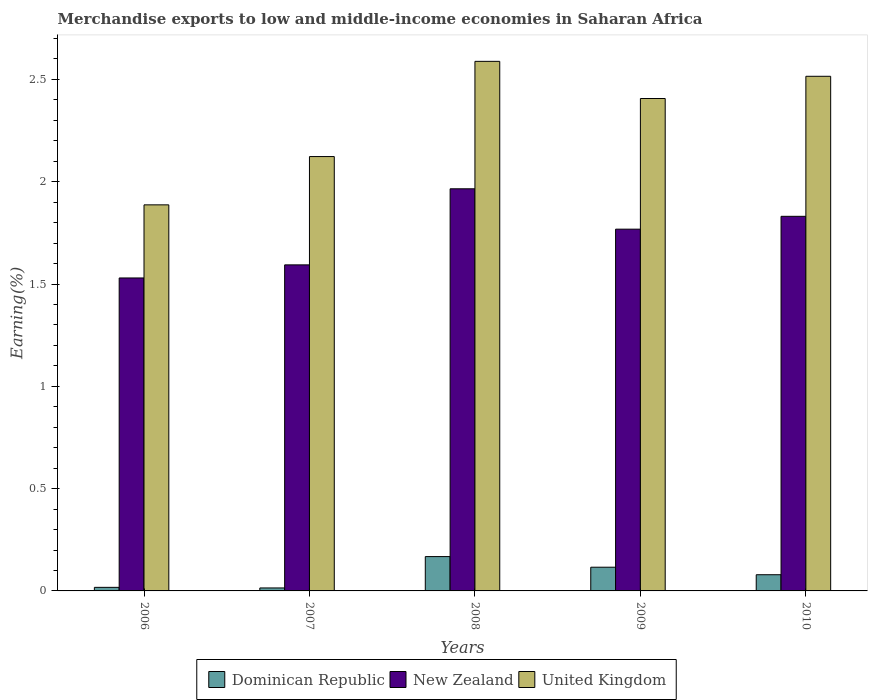How many different coloured bars are there?
Offer a terse response. 3. How many groups of bars are there?
Keep it short and to the point. 5. How many bars are there on the 5th tick from the left?
Keep it short and to the point. 3. How many bars are there on the 5th tick from the right?
Your answer should be very brief. 3. In how many cases, is the number of bars for a given year not equal to the number of legend labels?
Give a very brief answer. 0. What is the percentage of amount earned from merchandise exports in New Zealand in 2006?
Provide a succinct answer. 1.53. Across all years, what is the maximum percentage of amount earned from merchandise exports in Dominican Republic?
Make the answer very short. 0.17. Across all years, what is the minimum percentage of amount earned from merchandise exports in United Kingdom?
Your response must be concise. 1.89. In which year was the percentage of amount earned from merchandise exports in United Kingdom maximum?
Give a very brief answer. 2008. In which year was the percentage of amount earned from merchandise exports in United Kingdom minimum?
Provide a succinct answer. 2006. What is the total percentage of amount earned from merchandise exports in New Zealand in the graph?
Make the answer very short. 8.69. What is the difference between the percentage of amount earned from merchandise exports in New Zealand in 2007 and that in 2010?
Your response must be concise. -0.24. What is the difference between the percentage of amount earned from merchandise exports in New Zealand in 2008 and the percentage of amount earned from merchandise exports in Dominican Republic in 2006?
Ensure brevity in your answer.  1.95. What is the average percentage of amount earned from merchandise exports in New Zealand per year?
Offer a terse response. 1.74. In the year 2008, what is the difference between the percentage of amount earned from merchandise exports in Dominican Republic and percentage of amount earned from merchandise exports in United Kingdom?
Provide a short and direct response. -2.42. What is the ratio of the percentage of amount earned from merchandise exports in New Zealand in 2008 to that in 2009?
Provide a short and direct response. 1.11. What is the difference between the highest and the second highest percentage of amount earned from merchandise exports in New Zealand?
Provide a succinct answer. 0.13. What is the difference between the highest and the lowest percentage of amount earned from merchandise exports in New Zealand?
Provide a succinct answer. 0.44. What does the 3rd bar from the left in 2010 represents?
Keep it short and to the point. United Kingdom. What does the 3rd bar from the right in 2007 represents?
Your answer should be compact. Dominican Republic. How many bars are there?
Your response must be concise. 15. Are all the bars in the graph horizontal?
Keep it short and to the point. No. How many years are there in the graph?
Offer a very short reply. 5. Are the values on the major ticks of Y-axis written in scientific E-notation?
Your response must be concise. No. Does the graph contain grids?
Offer a terse response. No. What is the title of the graph?
Offer a very short reply. Merchandise exports to low and middle-income economies in Saharan Africa. What is the label or title of the X-axis?
Your response must be concise. Years. What is the label or title of the Y-axis?
Ensure brevity in your answer.  Earning(%). What is the Earning(%) in Dominican Republic in 2006?
Your response must be concise. 0.02. What is the Earning(%) in New Zealand in 2006?
Your response must be concise. 1.53. What is the Earning(%) in United Kingdom in 2006?
Offer a very short reply. 1.89. What is the Earning(%) in Dominican Republic in 2007?
Keep it short and to the point. 0.01. What is the Earning(%) of New Zealand in 2007?
Keep it short and to the point. 1.59. What is the Earning(%) of United Kingdom in 2007?
Offer a very short reply. 2.12. What is the Earning(%) of Dominican Republic in 2008?
Your answer should be very brief. 0.17. What is the Earning(%) in New Zealand in 2008?
Give a very brief answer. 1.97. What is the Earning(%) in United Kingdom in 2008?
Provide a succinct answer. 2.59. What is the Earning(%) of Dominican Republic in 2009?
Offer a terse response. 0.12. What is the Earning(%) of New Zealand in 2009?
Keep it short and to the point. 1.77. What is the Earning(%) in United Kingdom in 2009?
Make the answer very short. 2.41. What is the Earning(%) of Dominican Republic in 2010?
Ensure brevity in your answer.  0.08. What is the Earning(%) in New Zealand in 2010?
Offer a very short reply. 1.83. What is the Earning(%) of United Kingdom in 2010?
Your answer should be very brief. 2.52. Across all years, what is the maximum Earning(%) in Dominican Republic?
Your answer should be very brief. 0.17. Across all years, what is the maximum Earning(%) of New Zealand?
Your answer should be very brief. 1.97. Across all years, what is the maximum Earning(%) in United Kingdom?
Offer a very short reply. 2.59. Across all years, what is the minimum Earning(%) of Dominican Republic?
Your answer should be very brief. 0.01. Across all years, what is the minimum Earning(%) of New Zealand?
Make the answer very short. 1.53. Across all years, what is the minimum Earning(%) in United Kingdom?
Provide a succinct answer. 1.89. What is the total Earning(%) of Dominican Republic in the graph?
Your answer should be compact. 0.39. What is the total Earning(%) in New Zealand in the graph?
Give a very brief answer. 8.69. What is the total Earning(%) in United Kingdom in the graph?
Offer a very short reply. 11.52. What is the difference between the Earning(%) of Dominican Republic in 2006 and that in 2007?
Give a very brief answer. 0. What is the difference between the Earning(%) of New Zealand in 2006 and that in 2007?
Offer a very short reply. -0.06. What is the difference between the Earning(%) of United Kingdom in 2006 and that in 2007?
Give a very brief answer. -0.24. What is the difference between the Earning(%) of Dominican Republic in 2006 and that in 2008?
Ensure brevity in your answer.  -0.15. What is the difference between the Earning(%) in New Zealand in 2006 and that in 2008?
Offer a very short reply. -0.44. What is the difference between the Earning(%) of United Kingdom in 2006 and that in 2008?
Your answer should be very brief. -0.7. What is the difference between the Earning(%) in Dominican Republic in 2006 and that in 2009?
Make the answer very short. -0.1. What is the difference between the Earning(%) of New Zealand in 2006 and that in 2009?
Offer a terse response. -0.24. What is the difference between the Earning(%) of United Kingdom in 2006 and that in 2009?
Keep it short and to the point. -0.52. What is the difference between the Earning(%) in Dominican Republic in 2006 and that in 2010?
Make the answer very short. -0.06. What is the difference between the Earning(%) in New Zealand in 2006 and that in 2010?
Offer a very short reply. -0.3. What is the difference between the Earning(%) in United Kingdom in 2006 and that in 2010?
Keep it short and to the point. -0.63. What is the difference between the Earning(%) in Dominican Republic in 2007 and that in 2008?
Ensure brevity in your answer.  -0.15. What is the difference between the Earning(%) in New Zealand in 2007 and that in 2008?
Provide a succinct answer. -0.37. What is the difference between the Earning(%) of United Kingdom in 2007 and that in 2008?
Keep it short and to the point. -0.47. What is the difference between the Earning(%) of Dominican Republic in 2007 and that in 2009?
Give a very brief answer. -0.1. What is the difference between the Earning(%) in New Zealand in 2007 and that in 2009?
Make the answer very short. -0.17. What is the difference between the Earning(%) in United Kingdom in 2007 and that in 2009?
Your answer should be compact. -0.28. What is the difference between the Earning(%) of Dominican Republic in 2007 and that in 2010?
Give a very brief answer. -0.06. What is the difference between the Earning(%) of New Zealand in 2007 and that in 2010?
Offer a terse response. -0.24. What is the difference between the Earning(%) of United Kingdom in 2007 and that in 2010?
Give a very brief answer. -0.39. What is the difference between the Earning(%) of Dominican Republic in 2008 and that in 2009?
Ensure brevity in your answer.  0.05. What is the difference between the Earning(%) in New Zealand in 2008 and that in 2009?
Your answer should be compact. 0.2. What is the difference between the Earning(%) in United Kingdom in 2008 and that in 2009?
Provide a succinct answer. 0.18. What is the difference between the Earning(%) in Dominican Republic in 2008 and that in 2010?
Your response must be concise. 0.09. What is the difference between the Earning(%) in New Zealand in 2008 and that in 2010?
Give a very brief answer. 0.13. What is the difference between the Earning(%) in United Kingdom in 2008 and that in 2010?
Give a very brief answer. 0.07. What is the difference between the Earning(%) of Dominican Republic in 2009 and that in 2010?
Provide a succinct answer. 0.04. What is the difference between the Earning(%) of New Zealand in 2009 and that in 2010?
Make the answer very short. -0.06. What is the difference between the Earning(%) in United Kingdom in 2009 and that in 2010?
Your response must be concise. -0.11. What is the difference between the Earning(%) in Dominican Republic in 2006 and the Earning(%) in New Zealand in 2007?
Ensure brevity in your answer.  -1.58. What is the difference between the Earning(%) of Dominican Republic in 2006 and the Earning(%) of United Kingdom in 2007?
Your answer should be very brief. -2.11. What is the difference between the Earning(%) of New Zealand in 2006 and the Earning(%) of United Kingdom in 2007?
Offer a very short reply. -0.59. What is the difference between the Earning(%) of Dominican Republic in 2006 and the Earning(%) of New Zealand in 2008?
Your response must be concise. -1.95. What is the difference between the Earning(%) of Dominican Republic in 2006 and the Earning(%) of United Kingdom in 2008?
Provide a succinct answer. -2.57. What is the difference between the Earning(%) of New Zealand in 2006 and the Earning(%) of United Kingdom in 2008?
Give a very brief answer. -1.06. What is the difference between the Earning(%) in Dominican Republic in 2006 and the Earning(%) in New Zealand in 2009?
Your response must be concise. -1.75. What is the difference between the Earning(%) in Dominican Republic in 2006 and the Earning(%) in United Kingdom in 2009?
Keep it short and to the point. -2.39. What is the difference between the Earning(%) of New Zealand in 2006 and the Earning(%) of United Kingdom in 2009?
Your answer should be compact. -0.88. What is the difference between the Earning(%) of Dominican Republic in 2006 and the Earning(%) of New Zealand in 2010?
Provide a succinct answer. -1.81. What is the difference between the Earning(%) of Dominican Republic in 2006 and the Earning(%) of United Kingdom in 2010?
Keep it short and to the point. -2.5. What is the difference between the Earning(%) of New Zealand in 2006 and the Earning(%) of United Kingdom in 2010?
Provide a short and direct response. -0.99. What is the difference between the Earning(%) in Dominican Republic in 2007 and the Earning(%) in New Zealand in 2008?
Your answer should be very brief. -1.95. What is the difference between the Earning(%) in Dominican Republic in 2007 and the Earning(%) in United Kingdom in 2008?
Ensure brevity in your answer.  -2.57. What is the difference between the Earning(%) of New Zealand in 2007 and the Earning(%) of United Kingdom in 2008?
Give a very brief answer. -0.99. What is the difference between the Earning(%) in Dominican Republic in 2007 and the Earning(%) in New Zealand in 2009?
Keep it short and to the point. -1.75. What is the difference between the Earning(%) in Dominican Republic in 2007 and the Earning(%) in United Kingdom in 2009?
Provide a short and direct response. -2.39. What is the difference between the Earning(%) in New Zealand in 2007 and the Earning(%) in United Kingdom in 2009?
Make the answer very short. -0.81. What is the difference between the Earning(%) in Dominican Republic in 2007 and the Earning(%) in New Zealand in 2010?
Make the answer very short. -1.82. What is the difference between the Earning(%) in Dominican Republic in 2007 and the Earning(%) in United Kingdom in 2010?
Your answer should be compact. -2.5. What is the difference between the Earning(%) of New Zealand in 2007 and the Earning(%) of United Kingdom in 2010?
Keep it short and to the point. -0.92. What is the difference between the Earning(%) of Dominican Republic in 2008 and the Earning(%) of New Zealand in 2009?
Your response must be concise. -1.6. What is the difference between the Earning(%) in Dominican Republic in 2008 and the Earning(%) in United Kingdom in 2009?
Offer a very short reply. -2.24. What is the difference between the Earning(%) in New Zealand in 2008 and the Earning(%) in United Kingdom in 2009?
Keep it short and to the point. -0.44. What is the difference between the Earning(%) in Dominican Republic in 2008 and the Earning(%) in New Zealand in 2010?
Your answer should be compact. -1.66. What is the difference between the Earning(%) in Dominican Republic in 2008 and the Earning(%) in United Kingdom in 2010?
Provide a short and direct response. -2.35. What is the difference between the Earning(%) of New Zealand in 2008 and the Earning(%) of United Kingdom in 2010?
Keep it short and to the point. -0.55. What is the difference between the Earning(%) in Dominican Republic in 2009 and the Earning(%) in New Zealand in 2010?
Offer a very short reply. -1.72. What is the difference between the Earning(%) of Dominican Republic in 2009 and the Earning(%) of United Kingdom in 2010?
Make the answer very short. -2.4. What is the difference between the Earning(%) in New Zealand in 2009 and the Earning(%) in United Kingdom in 2010?
Provide a succinct answer. -0.75. What is the average Earning(%) of Dominican Republic per year?
Provide a succinct answer. 0.08. What is the average Earning(%) of New Zealand per year?
Your answer should be very brief. 1.74. What is the average Earning(%) of United Kingdom per year?
Provide a succinct answer. 2.3. In the year 2006, what is the difference between the Earning(%) in Dominican Republic and Earning(%) in New Zealand?
Your answer should be very brief. -1.51. In the year 2006, what is the difference between the Earning(%) of Dominican Republic and Earning(%) of United Kingdom?
Offer a very short reply. -1.87. In the year 2006, what is the difference between the Earning(%) in New Zealand and Earning(%) in United Kingdom?
Keep it short and to the point. -0.36. In the year 2007, what is the difference between the Earning(%) of Dominican Republic and Earning(%) of New Zealand?
Give a very brief answer. -1.58. In the year 2007, what is the difference between the Earning(%) of Dominican Republic and Earning(%) of United Kingdom?
Your answer should be compact. -2.11. In the year 2007, what is the difference between the Earning(%) in New Zealand and Earning(%) in United Kingdom?
Your answer should be very brief. -0.53. In the year 2008, what is the difference between the Earning(%) in Dominican Republic and Earning(%) in New Zealand?
Offer a terse response. -1.8. In the year 2008, what is the difference between the Earning(%) of Dominican Republic and Earning(%) of United Kingdom?
Your response must be concise. -2.42. In the year 2008, what is the difference between the Earning(%) in New Zealand and Earning(%) in United Kingdom?
Provide a succinct answer. -0.62. In the year 2009, what is the difference between the Earning(%) of Dominican Republic and Earning(%) of New Zealand?
Provide a short and direct response. -1.65. In the year 2009, what is the difference between the Earning(%) of Dominican Republic and Earning(%) of United Kingdom?
Ensure brevity in your answer.  -2.29. In the year 2009, what is the difference between the Earning(%) of New Zealand and Earning(%) of United Kingdom?
Your response must be concise. -0.64. In the year 2010, what is the difference between the Earning(%) of Dominican Republic and Earning(%) of New Zealand?
Provide a short and direct response. -1.75. In the year 2010, what is the difference between the Earning(%) in Dominican Republic and Earning(%) in United Kingdom?
Your answer should be very brief. -2.44. In the year 2010, what is the difference between the Earning(%) of New Zealand and Earning(%) of United Kingdom?
Provide a succinct answer. -0.68. What is the ratio of the Earning(%) in Dominican Republic in 2006 to that in 2007?
Your response must be concise. 1.2. What is the ratio of the Earning(%) in New Zealand in 2006 to that in 2007?
Provide a succinct answer. 0.96. What is the ratio of the Earning(%) in United Kingdom in 2006 to that in 2007?
Make the answer very short. 0.89. What is the ratio of the Earning(%) of Dominican Republic in 2006 to that in 2008?
Your answer should be compact. 0.1. What is the ratio of the Earning(%) of New Zealand in 2006 to that in 2008?
Offer a very short reply. 0.78. What is the ratio of the Earning(%) of United Kingdom in 2006 to that in 2008?
Your answer should be compact. 0.73. What is the ratio of the Earning(%) in Dominican Republic in 2006 to that in 2009?
Your response must be concise. 0.15. What is the ratio of the Earning(%) of New Zealand in 2006 to that in 2009?
Ensure brevity in your answer.  0.87. What is the ratio of the Earning(%) of United Kingdom in 2006 to that in 2009?
Provide a short and direct response. 0.78. What is the ratio of the Earning(%) of Dominican Republic in 2006 to that in 2010?
Your answer should be very brief. 0.22. What is the ratio of the Earning(%) in New Zealand in 2006 to that in 2010?
Offer a terse response. 0.84. What is the ratio of the Earning(%) of United Kingdom in 2006 to that in 2010?
Make the answer very short. 0.75. What is the ratio of the Earning(%) in Dominican Republic in 2007 to that in 2008?
Your response must be concise. 0.09. What is the ratio of the Earning(%) of New Zealand in 2007 to that in 2008?
Give a very brief answer. 0.81. What is the ratio of the Earning(%) in United Kingdom in 2007 to that in 2008?
Ensure brevity in your answer.  0.82. What is the ratio of the Earning(%) in Dominican Republic in 2007 to that in 2009?
Your answer should be very brief. 0.13. What is the ratio of the Earning(%) of New Zealand in 2007 to that in 2009?
Your answer should be very brief. 0.9. What is the ratio of the Earning(%) in United Kingdom in 2007 to that in 2009?
Ensure brevity in your answer.  0.88. What is the ratio of the Earning(%) of Dominican Republic in 2007 to that in 2010?
Provide a short and direct response. 0.18. What is the ratio of the Earning(%) of New Zealand in 2007 to that in 2010?
Your answer should be very brief. 0.87. What is the ratio of the Earning(%) in United Kingdom in 2007 to that in 2010?
Your answer should be very brief. 0.84. What is the ratio of the Earning(%) in Dominican Republic in 2008 to that in 2009?
Make the answer very short. 1.45. What is the ratio of the Earning(%) in New Zealand in 2008 to that in 2009?
Your answer should be compact. 1.11. What is the ratio of the Earning(%) in United Kingdom in 2008 to that in 2009?
Provide a succinct answer. 1.08. What is the ratio of the Earning(%) of Dominican Republic in 2008 to that in 2010?
Give a very brief answer. 2.12. What is the ratio of the Earning(%) in New Zealand in 2008 to that in 2010?
Give a very brief answer. 1.07. What is the ratio of the Earning(%) in Dominican Republic in 2009 to that in 2010?
Give a very brief answer. 1.46. What is the ratio of the Earning(%) of New Zealand in 2009 to that in 2010?
Keep it short and to the point. 0.97. What is the ratio of the Earning(%) in United Kingdom in 2009 to that in 2010?
Offer a terse response. 0.96. What is the difference between the highest and the second highest Earning(%) of Dominican Republic?
Make the answer very short. 0.05. What is the difference between the highest and the second highest Earning(%) of New Zealand?
Provide a succinct answer. 0.13. What is the difference between the highest and the second highest Earning(%) of United Kingdom?
Make the answer very short. 0.07. What is the difference between the highest and the lowest Earning(%) of Dominican Republic?
Keep it short and to the point. 0.15. What is the difference between the highest and the lowest Earning(%) in New Zealand?
Your answer should be compact. 0.44. What is the difference between the highest and the lowest Earning(%) in United Kingdom?
Offer a terse response. 0.7. 